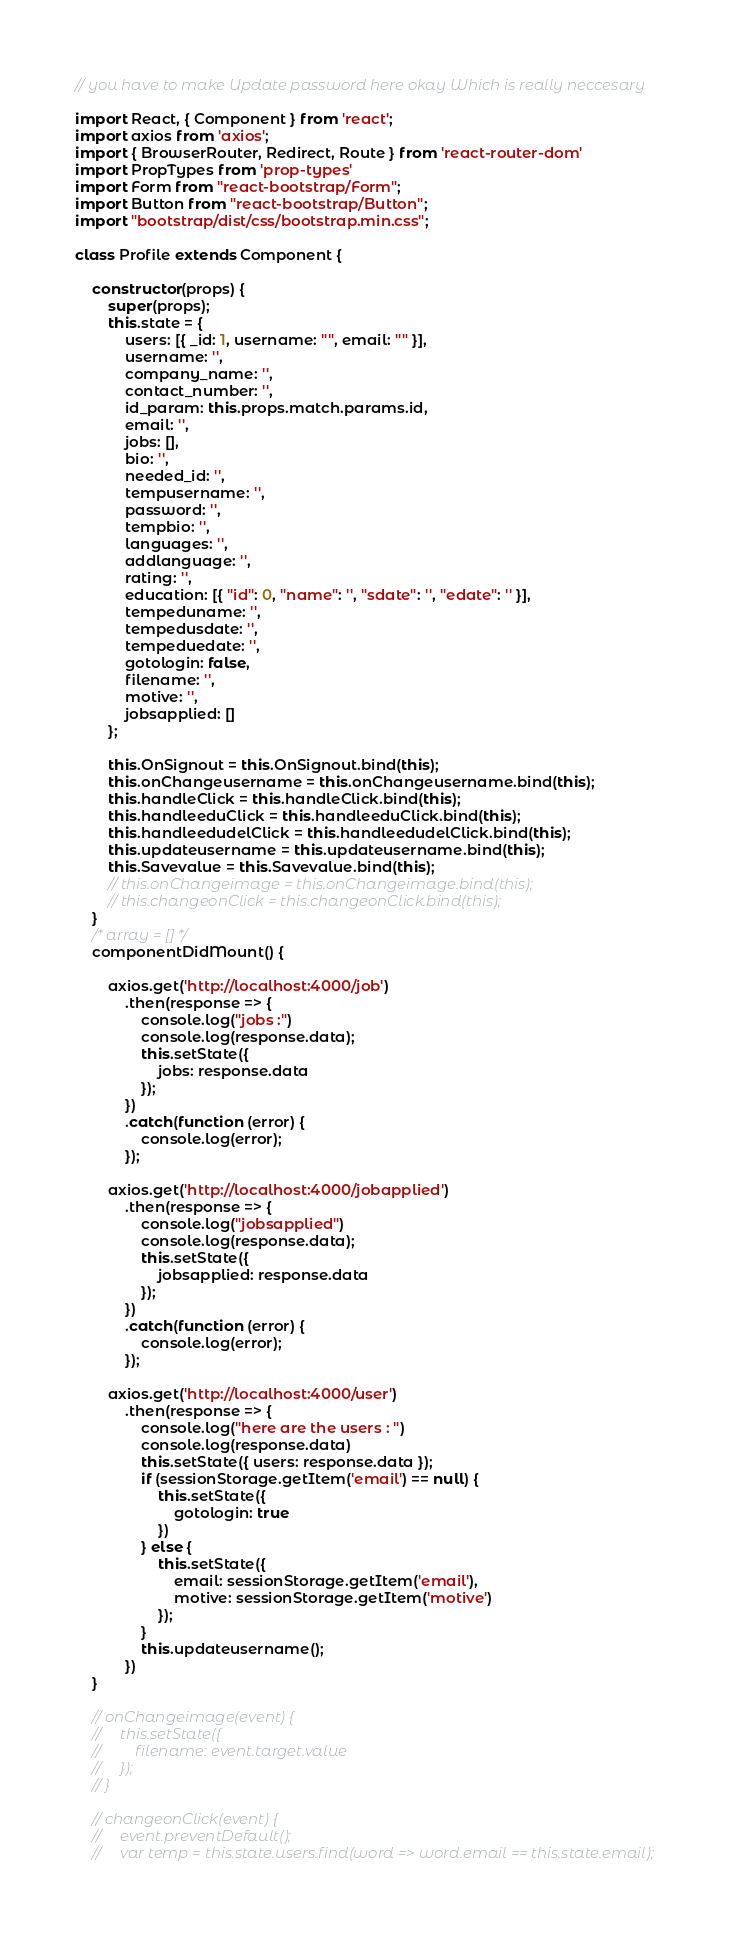<code> <loc_0><loc_0><loc_500><loc_500><_JavaScript_>// you have to make Update password here okay Which is really neccesary

import React, { Component } from 'react';
import axios from 'axios';
import { BrowserRouter, Redirect, Route } from 'react-router-dom'
import PropTypes from 'prop-types'
import Form from "react-bootstrap/Form";
import Button from "react-bootstrap/Button";
import "bootstrap/dist/css/bootstrap.min.css";

class Profile extends Component {

    constructor(props) {
        super(props);
        this.state = {
            users: [{ _id: 1, username: "", email: "" }],
            username: '',
            company_name: '',
            contact_number: '',
            id_param: this.props.match.params.id,
            email: '',
            jobs: [],
            bio: '',
            needed_id: '',
            tempusername: '',
            password: '',
            tempbio: '',
            languages: '',
            addlanguage: '',
            rating: '',
            education: [{ "id": 0, "name": '', "sdate": '', "edate": '' }],
            tempeduname: '',
            tempedusdate: '',
            tempeduedate: '',
            gotologin: false,
            filename: '',
            motive: '',
            jobsapplied: []
        };

        this.OnSignout = this.OnSignout.bind(this);
        this.onChangeusername = this.onChangeusername.bind(this);
        this.handleClick = this.handleClick.bind(this);
        this.handleeduClick = this.handleeduClick.bind(this);
        this.handleedudelClick = this.handleedudelClick.bind(this);
        this.updateusername = this.updateusername.bind(this);
        this.Savevalue = this.Savevalue.bind(this);
        // this.onChangeimage = this.onChangeimage.bind(this);
        // this.changeonClick = this.changeonClick.bind(this);
    }
    /* array = [] */
    componentDidMount() {

        axios.get('http://localhost:4000/job')
            .then(response => {
                console.log("jobs :")
                console.log(response.data);
                this.setState({
                    jobs: response.data
                });
            })
            .catch(function (error) {
                console.log(error);
            });

        axios.get('http://localhost:4000/jobapplied')
            .then(response => {
                console.log("jobsapplied")
                console.log(response.data);
                this.setState({
                    jobsapplied: response.data
                });
            })
            .catch(function (error) {
                console.log(error);
            });

        axios.get('http://localhost:4000/user')
            .then(response => {
                console.log("here are the users : ")
                console.log(response.data)
                this.setState({ users: response.data });
                if (sessionStorage.getItem('email') == null) {
                    this.setState({
                        gotologin: true
                    })
                } else {
                    this.setState({
                        email: sessionStorage.getItem('email'),
                        motive: sessionStorage.getItem('motive')
                    });
                }
                this.updateusername();
            })
    }

    // onChangeimage(event) {
    //     this.setState({
    //         filename: event.target.value
    //     });
    // }

    // changeonClick(event) {
    //     event.preventDefault();
    //     var temp = this.state.users.find(word => word.email == this.state.email);</code> 